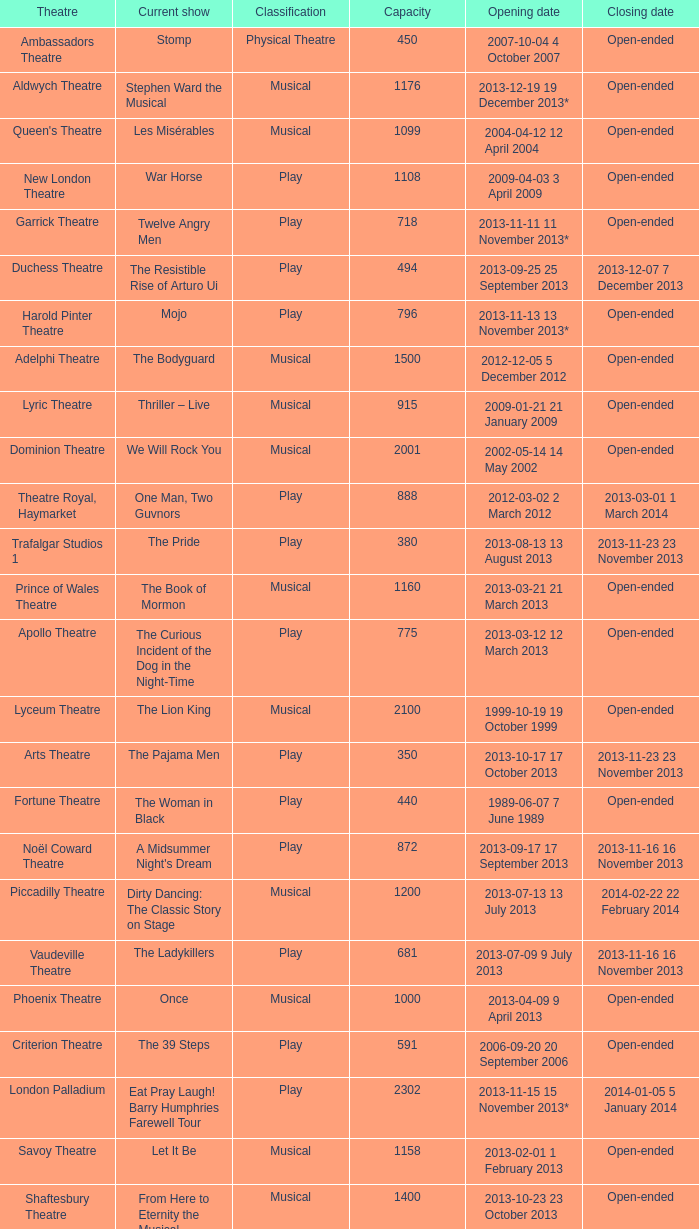What is the opening date of the musical at the adelphi theatre? 2012-12-05 5 December 2012. 